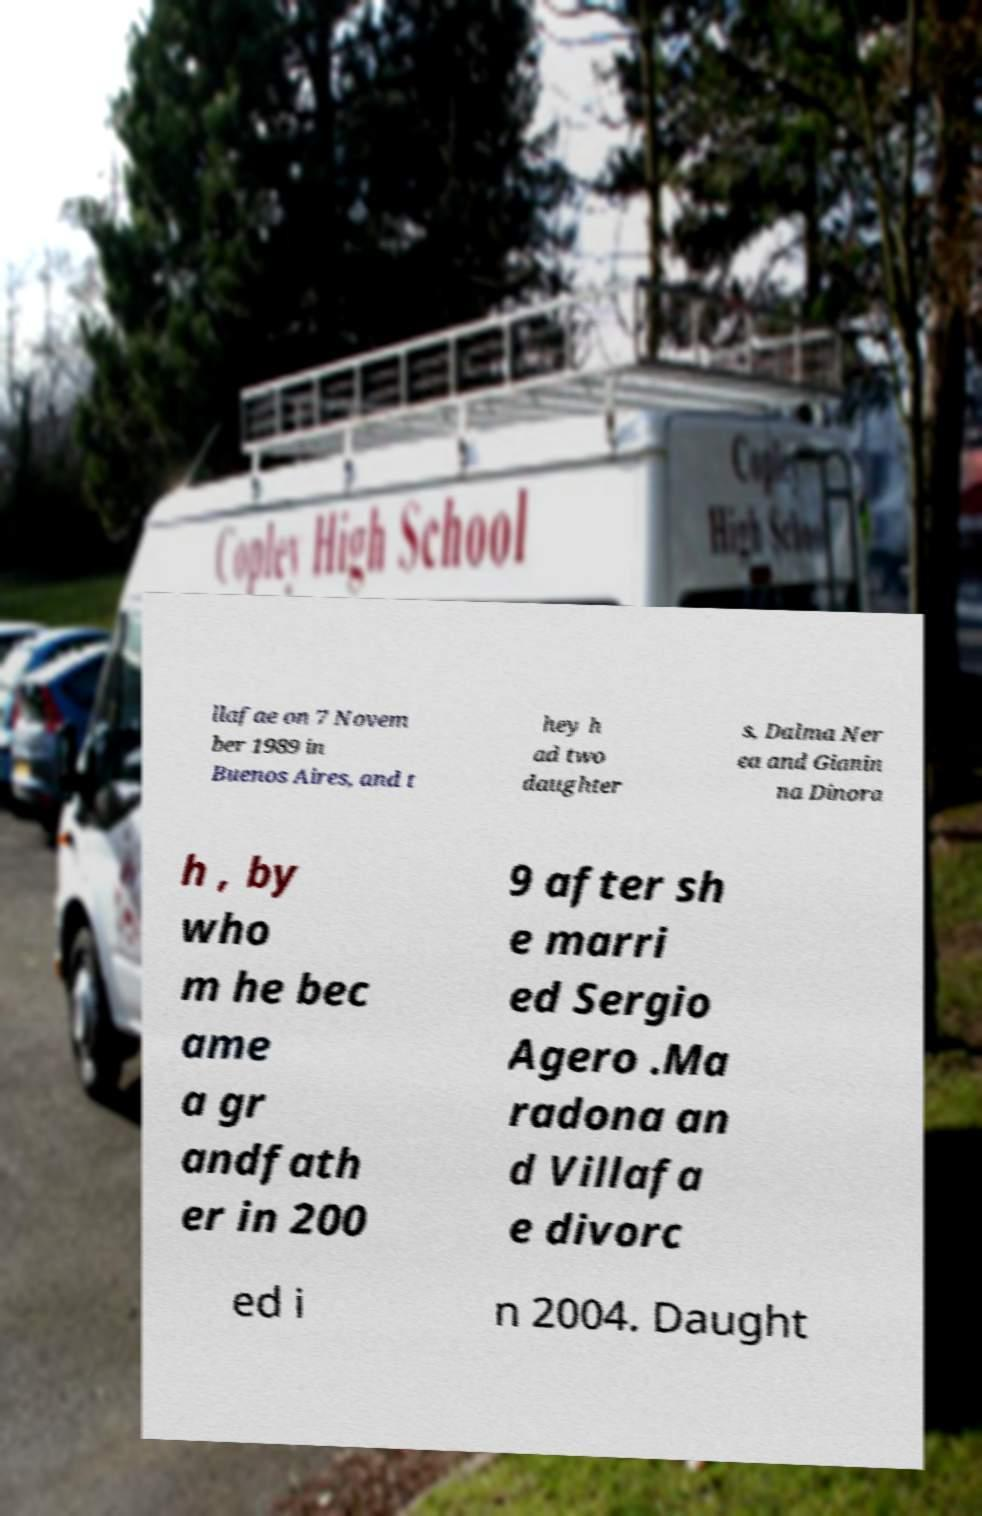Can you accurately transcribe the text from the provided image for me? llafae on 7 Novem ber 1989 in Buenos Aires, and t hey h ad two daughter s, Dalma Ner ea and Gianin na Dinora h , by who m he bec ame a gr andfath er in 200 9 after sh e marri ed Sergio Agero .Ma radona an d Villafa e divorc ed i n 2004. Daught 